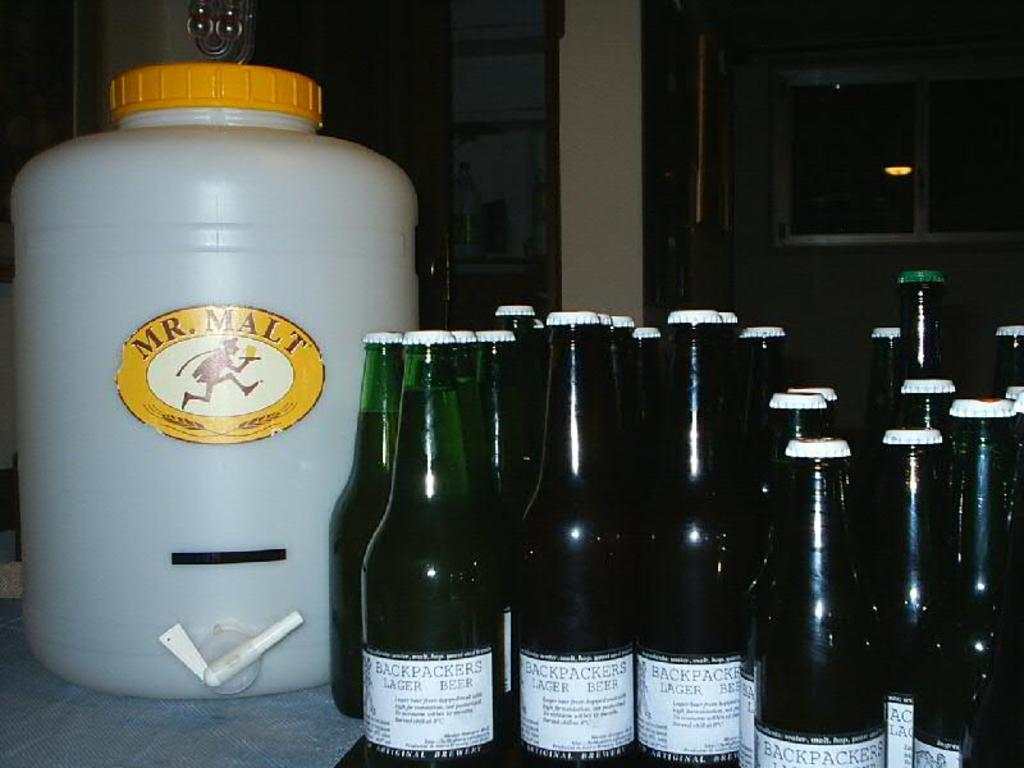<image>
Provide a brief description of the given image. a big tub of Mr Malt near green bottles of beer 